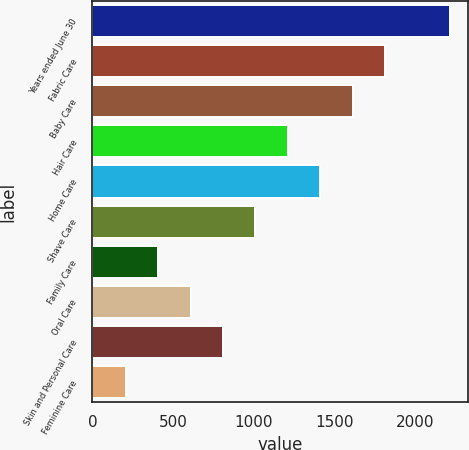<chart> <loc_0><loc_0><loc_500><loc_500><bar_chart><fcel>Years ended June 30<fcel>Fabric Care<fcel>Baby Care<fcel>Hair Care<fcel>Home Care<fcel>Shave Care<fcel>Family Care<fcel>Oral Care<fcel>Skin and Personal Care<fcel>Feminine Care<nl><fcel>2218.2<fcel>1815.8<fcel>1614.6<fcel>1212.2<fcel>1413.4<fcel>1011<fcel>407.4<fcel>608.6<fcel>809.8<fcel>206.2<nl></chart> 